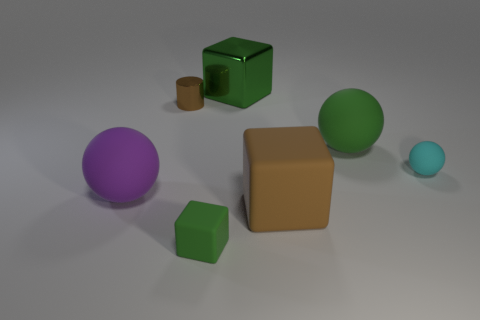Add 2 yellow cubes. How many objects exist? 9 Subtract all cylinders. How many objects are left? 6 Subtract all brown matte things. Subtract all small spheres. How many objects are left? 5 Add 2 green things. How many green things are left? 5 Add 6 shiny cylinders. How many shiny cylinders exist? 7 Subtract 0 gray blocks. How many objects are left? 7 